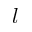<formula> <loc_0><loc_0><loc_500><loc_500>l</formula> 